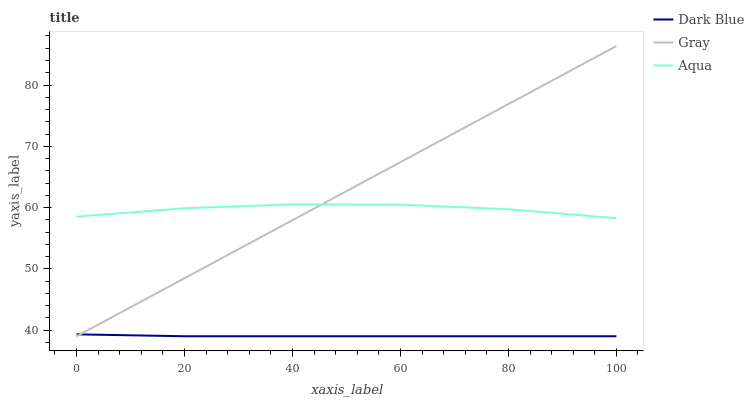Does Dark Blue have the minimum area under the curve?
Answer yes or no. Yes. Does Gray have the maximum area under the curve?
Answer yes or no. Yes. Does Aqua have the minimum area under the curve?
Answer yes or no. No. Does Aqua have the maximum area under the curve?
Answer yes or no. No. Is Gray the smoothest?
Answer yes or no. Yes. Is Aqua the roughest?
Answer yes or no. Yes. Is Aqua the smoothest?
Answer yes or no. No. Is Gray the roughest?
Answer yes or no. No. Does Dark Blue have the lowest value?
Answer yes or no. Yes. Does Aqua have the lowest value?
Answer yes or no. No. Does Gray have the highest value?
Answer yes or no. Yes. Does Aqua have the highest value?
Answer yes or no. No. Is Dark Blue less than Aqua?
Answer yes or no. Yes. Is Aqua greater than Dark Blue?
Answer yes or no. Yes. Does Gray intersect Dark Blue?
Answer yes or no. Yes. Is Gray less than Dark Blue?
Answer yes or no. No. Is Gray greater than Dark Blue?
Answer yes or no. No. Does Dark Blue intersect Aqua?
Answer yes or no. No. 